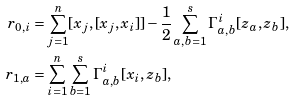Convert formula to latex. <formula><loc_0><loc_0><loc_500><loc_500>r _ { 0 , i } & = \sum _ { j = 1 } ^ { n } [ x _ { j } , [ x _ { j } , x _ { i } ] ] - \frac { 1 } { 2 } \sum _ { a , b = 1 } ^ { s } \Gamma ^ { i } _ { a , b } [ z _ { a } , z _ { b } ] , \\ r _ { 1 , a } & = \sum _ { i = 1 } ^ { n } \sum _ { b = 1 } ^ { s } \Gamma _ { a , b } ^ { i } [ x _ { i } , z _ { b } ] ,</formula> 